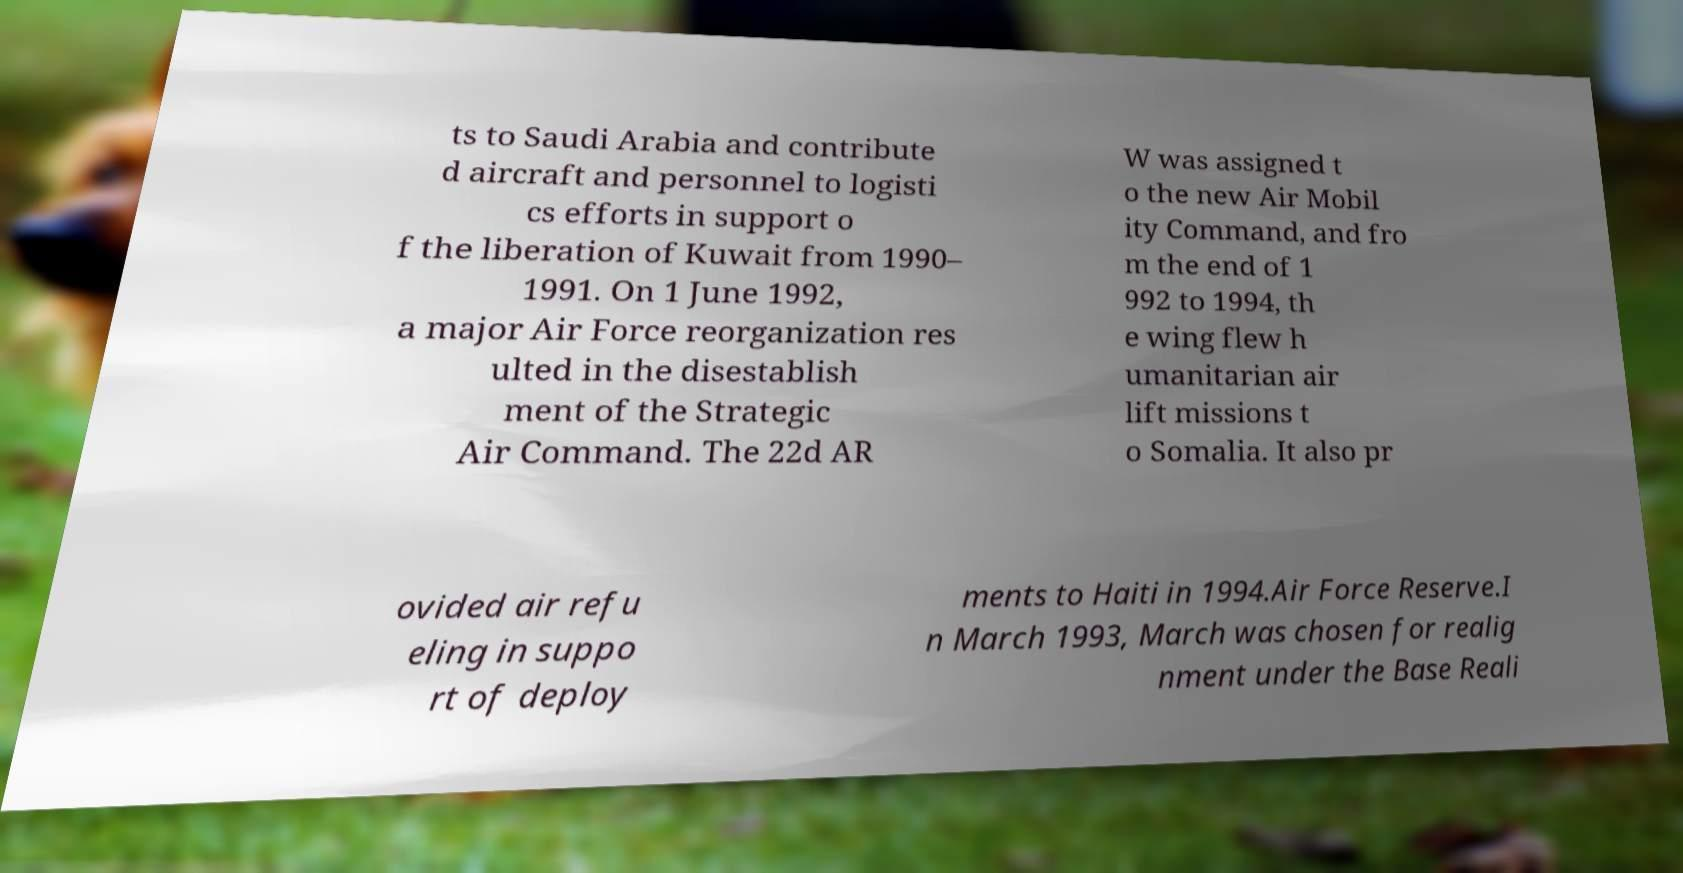There's text embedded in this image that I need extracted. Can you transcribe it verbatim? ts to Saudi Arabia and contribute d aircraft and personnel to logisti cs efforts in support o f the liberation of Kuwait from 1990– 1991. On 1 June 1992, a major Air Force reorganization res ulted in the disestablish ment of the Strategic Air Command. The 22d AR W was assigned t o the new Air Mobil ity Command, and fro m the end of 1 992 to 1994, th e wing flew h umanitarian air lift missions t o Somalia. It also pr ovided air refu eling in suppo rt of deploy ments to Haiti in 1994.Air Force Reserve.I n March 1993, March was chosen for realig nment under the Base Reali 